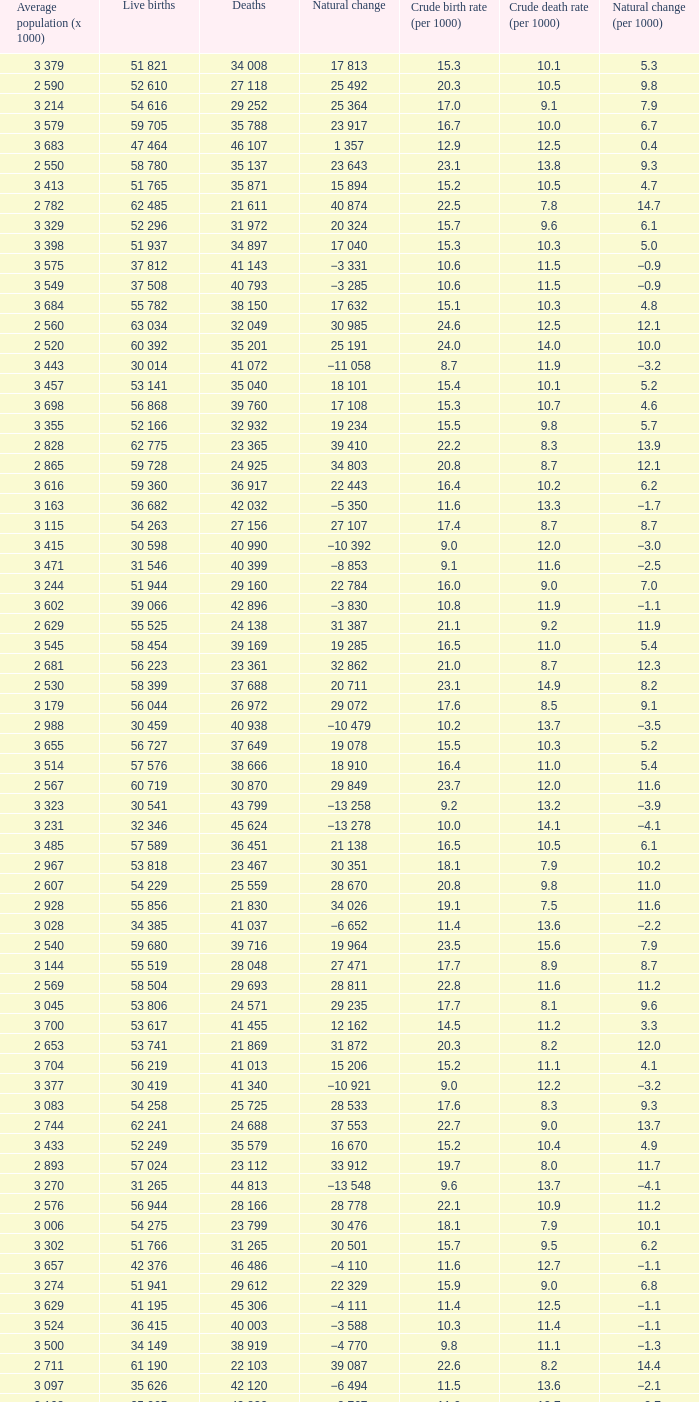Which Live births have a Natural change (per 1000) of 12.0? 53 741. 